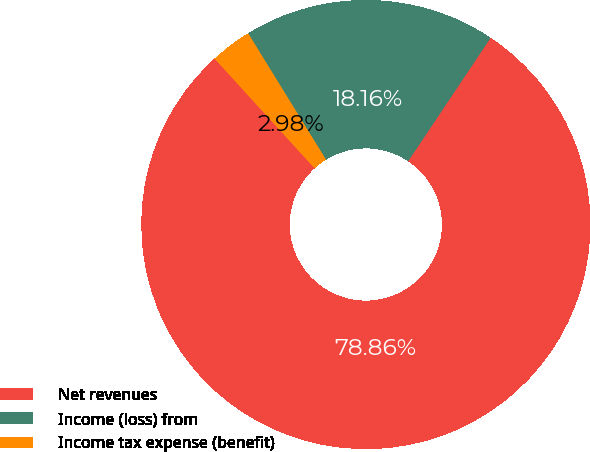Convert chart to OTSL. <chart><loc_0><loc_0><loc_500><loc_500><pie_chart><fcel>Net revenues<fcel>Income (loss) from<fcel>Income tax expense (benefit)<nl><fcel>78.86%<fcel>18.16%<fcel>2.98%<nl></chart> 